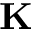Convert formula to latex. <formula><loc_0><loc_0><loc_500><loc_500>K</formula> 